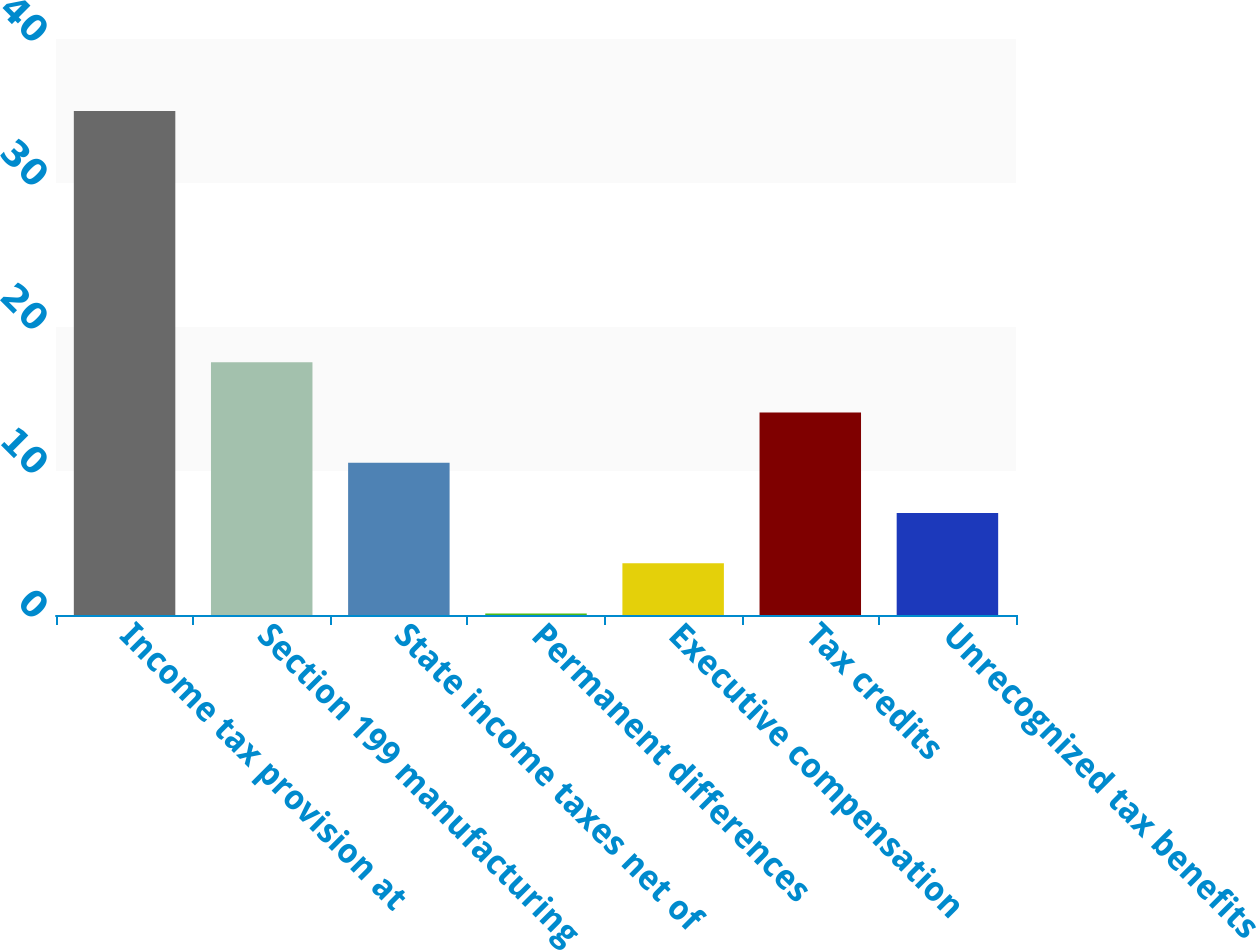<chart> <loc_0><loc_0><loc_500><loc_500><bar_chart><fcel>Income tax provision at<fcel>Section 199 manufacturing<fcel>State income taxes net of<fcel>Permanent differences<fcel>Executive compensation<fcel>Tax credits<fcel>Unrecognized tax benefits<nl><fcel>35<fcel>17.55<fcel>10.57<fcel>0.1<fcel>3.59<fcel>14.06<fcel>7.08<nl></chart> 